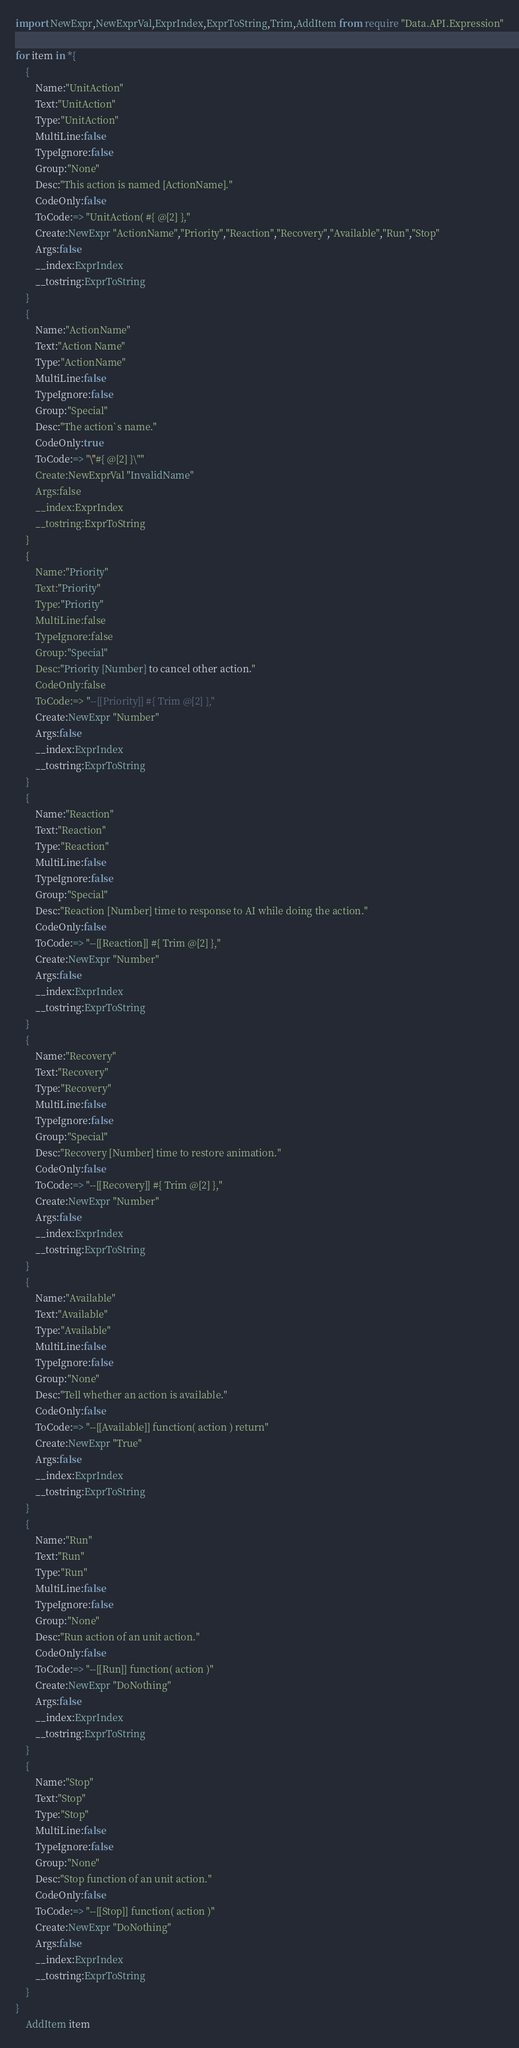<code> <loc_0><loc_0><loc_500><loc_500><_MoonScript_>import NewExpr,NewExprVal,ExprIndex,ExprToString,Trim,AddItem from require "Data.API.Expression"

for item in *{
	{
		Name:"UnitAction"
		Text:"UnitAction"
		Type:"UnitAction"
		MultiLine:false
		TypeIgnore:false
		Group:"None"
		Desc:"This action is named [ActionName]."
		CodeOnly:false
		ToCode:=> "UnitAction( #{ @[2] },"
		Create:NewExpr "ActionName","Priority","Reaction","Recovery","Available","Run","Stop"
		Args:false
		__index:ExprIndex
		__tostring:ExprToString
	}
	{
		Name:"ActionName"
		Text:"Action Name"
		Type:"ActionName"
		MultiLine:false
		TypeIgnore:false
		Group:"Special"
		Desc:"The action`s name."
		CodeOnly:true
		ToCode:=> "\"#{ @[2] }\""
		Create:NewExprVal "InvalidName"
		Args:false
		__index:ExprIndex
		__tostring:ExprToString
	}
	{
		Name:"Priority"
		Text:"Priority"
		Type:"Priority"
		MultiLine:false
		TypeIgnore:false
		Group:"Special"
		Desc:"Priority [Number] to cancel other action."
		CodeOnly:false
		ToCode:=> "--[[Priority]] #{ Trim @[2] },"
		Create:NewExpr "Number"
		Args:false
		__index:ExprIndex
		__tostring:ExprToString
	}
	{
		Name:"Reaction"
		Text:"Reaction"
		Type:"Reaction"
		MultiLine:false
		TypeIgnore:false
		Group:"Special"
		Desc:"Reaction [Number] time to response to AI while doing the action."
		CodeOnly:false
		ToCode:=> "--[[Reaction]] #{ Trim @[2] },"
		Create:NewExpr "Number"
		Args:false
		__index:ExprIndex
		__tostring:ExprToString
	}
	{
		Name:"Recovery"
		Text:"Recovery"
		Type:"Recovery"
		MultiLine:false
		TypeIgnore:false
		Group:"Special"
		Desc:"Recovery [Number] time to restore animation."
		CodeOnly:false
		ToCode:=> "--[[Recovery]] #{ Trim @[2] },"
		Create:NewExpr "Number"
		Args:false
		__index:ExprIndex
		__tostring:ExprToString
	}
	{
		Name:"Available"
		Text:"Available"
		Type:"Available"
		MultiLine:false
		TypeIgnore:false
		Group:"None"
		Desc:"Tell whether an action is available."
		CodeOnly:false
		ToCode:=> "--[[Available]] function( action ) return"
		Create:NewExpr "True"
		Args:false
		__index:ExprIndex
		__tostring:ExprToString
	}
	{
		Name:"Run"
		Text:"Run"
		Type:"Run"
		MultiLine:false
		TypeIgnore:false
		Group:"None"
		Desc:"Run action of an unit action."
		CodeOnly:false
		ToCode:=> "--[[Run]] function( action )"
		Create:NewExpr "DoNothing"
		Args:false
		__index:ExprIndex
		__tostring:ExprToString
	}
	{
		Name:"Stop"
		Text:"Stop"
		Type:"Stop"
		MultiLine:false
		TypeIgnore:false
		Group:"None"
		Desc:"Stop function of an unit action."
		CodeOnly:false
		ToCode:=> "--[[Stop]] function( action )"
		Create:NewExpr "DoNothing"
		Args:false
		__index:ExprIndex
		__tostring:ExprToString
	}
}
	AddItem item
</code> 